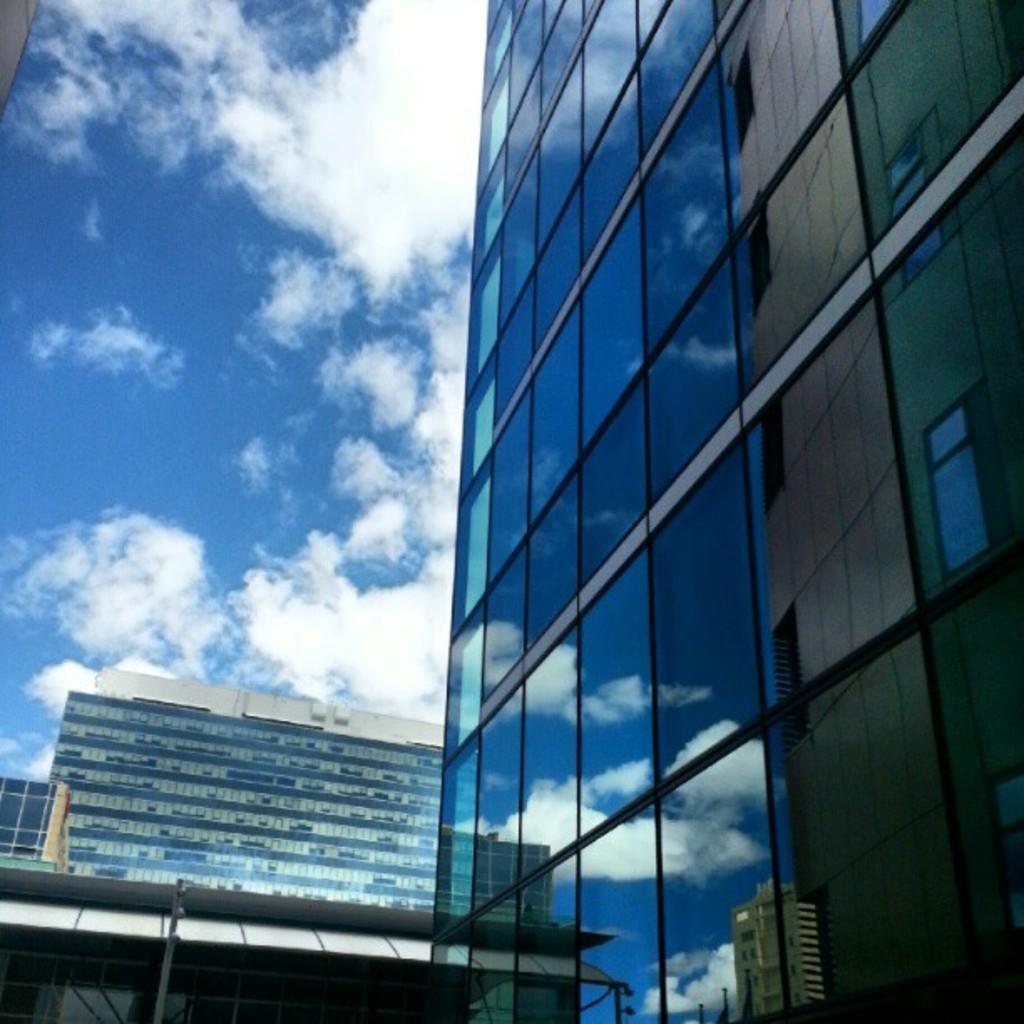Please provide a concise description of this image. In this picture we can see there are buildings and behind the buildings there is the cloudy sky. 